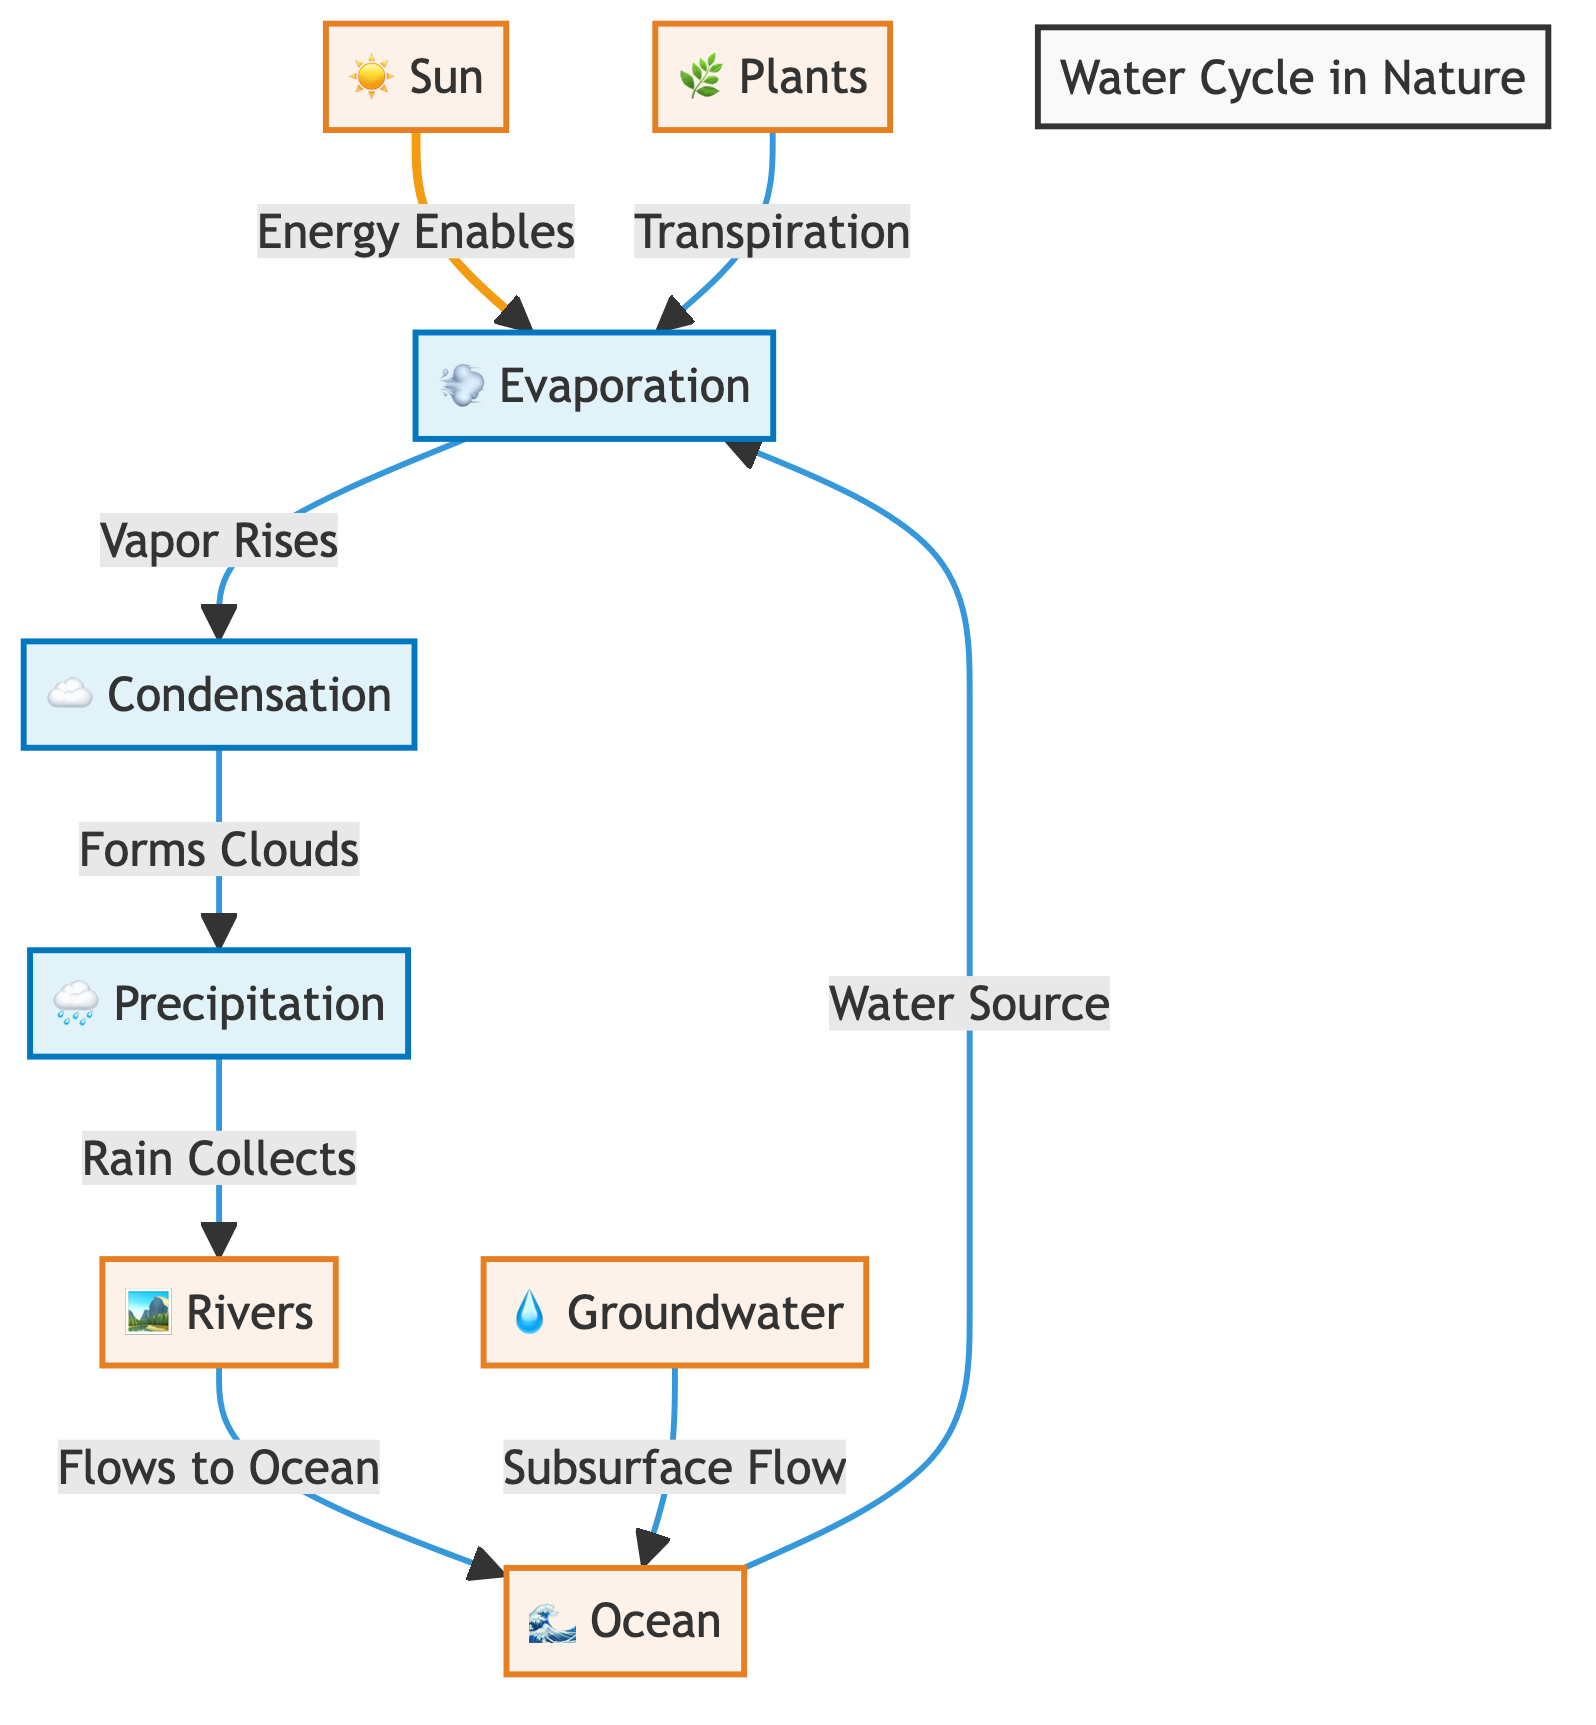What are the main processes shown in the water cycle diagram? The diagram shows three main processes: evaporation, condensation, and precipitation. These processes are represented as nodes that describe the movement of water in different forms through the cycle.
Answer: evaporation, condensation, precipitation How does evaporation occur in the diagram? According to the diagram, evaporation occurs due to energy supplied by the sun and the ocean serving as the water source. Together, these elements initiate the process of converting liquid water into vapor.
Answer: Sun and ocean What happens after condensation in the diagram? Following condensation, the diagram indicates that vapor forms clouds, which then leads to precipitation. This outlines the flow of water transitioning from vapor back to liquid in the form of water droplets.
Answer: Forms clouds How many elements are represented in the diagram? The diagram features four primary elemental nodes: the sun, ocean, rivers, groundwater, and plants. By counting these nodes, we can ascertain that there are five main elements in the water cycle.
Answer: Five What is the role of plants in the water cycle according to the diagram? The diagram illustrates that plants contribute to the evaporation process through transpiration, which means releasing moisture into the atmosphere from their leaves.
Answer: Transpiration Where does the water collected from precipitation flow according to the diagram? According to the diagram, precipitation collects in rivers, which are depicted as a conduit for transporting water back to the ocean, indicating a cyclical flow pattern.
Answer: Rivers What initiates the process of evaporation in the water cycle? The initiation of evaporation in the water cycle, based on the diagram, is driven by the energy from the sun, as it warms the water in the ocean, enabling its transformation into vapor.
Answer: Energy from the sun What does groundwater contribute to in the water cycle? The groundwater contributes to the cycle by undergoing subsurface flow that eventually returns water to the ocean, illustrating the interconnectedness of different water sources and pathways.
Answer: Subsurface flow What forms clouds according to the diagram? The diagram specifies that clouds are formed during the condensation process, where evaporated water vapor cools and condenses to create cloud formations in the atmosphere.
Answer: Condensation 